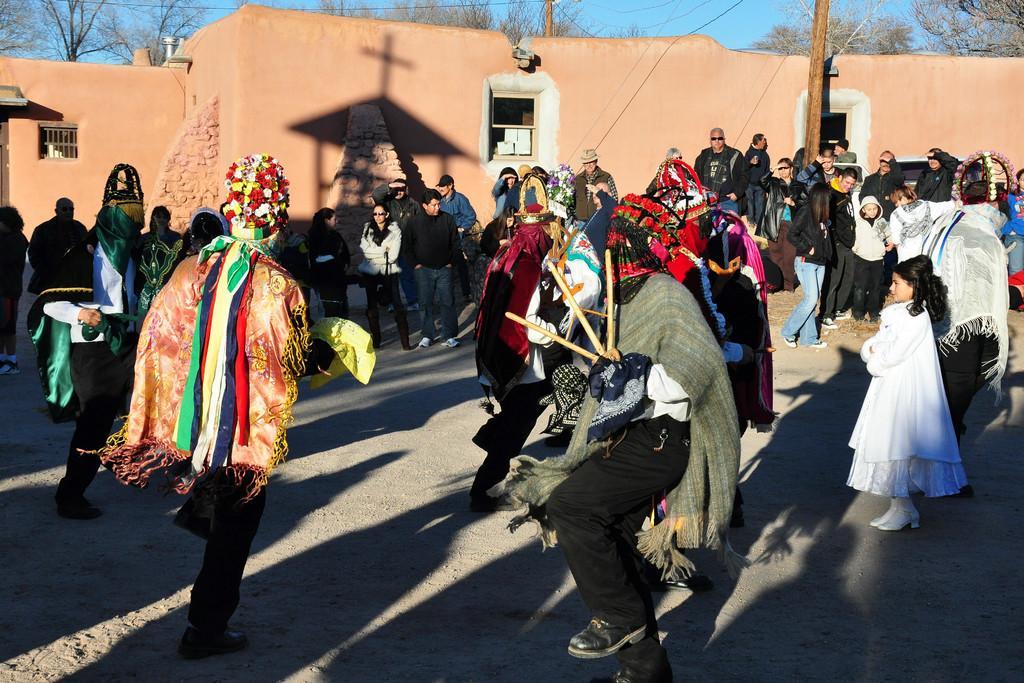Describe this image in one or two sentences. In this image we can see a group of people. Behind the persons we can see a wall and there is a shadow on it and behind the wall there are some trees visible. 